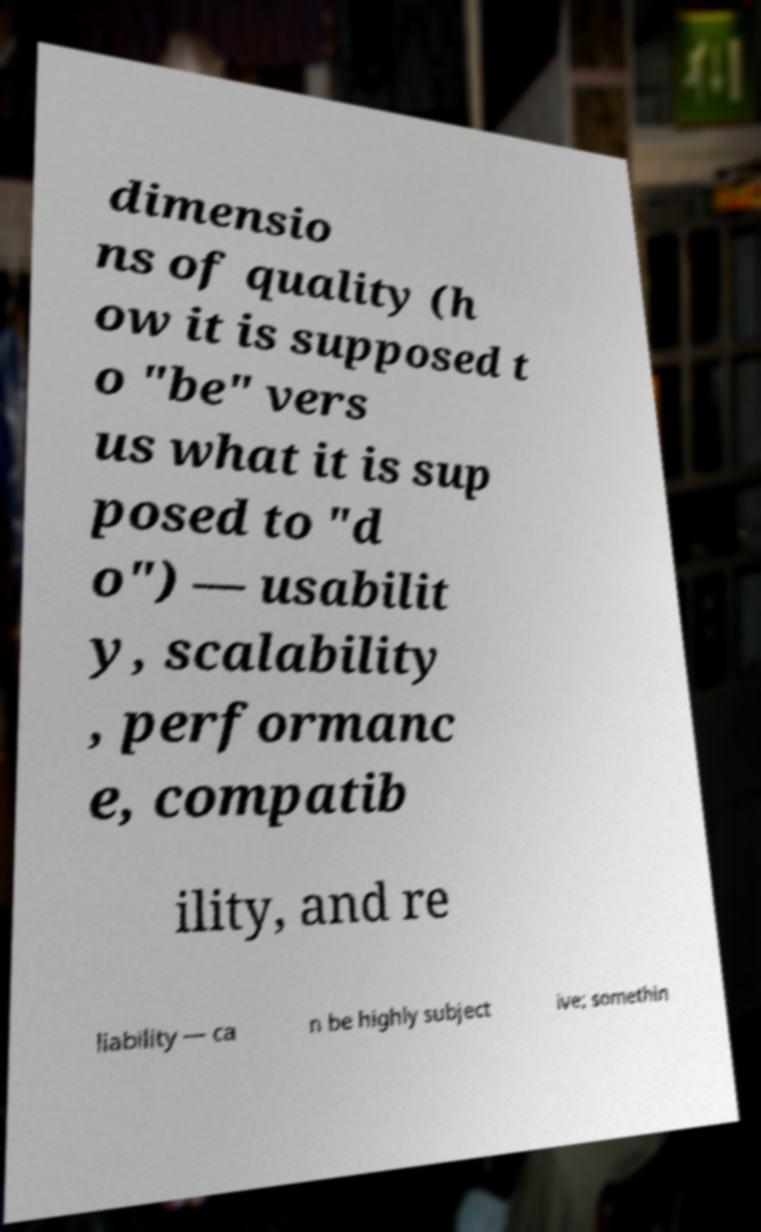For documentation purposes, I need the text within this image transcribed. Could you provide that? dimensio ns of quality (h ow it is supposed t o "be" vers us what it is sup posed to "d o") — usabilit y, scalability , performanc e, compatib ility, and re liability — ca n be highly subject ive; somethin 